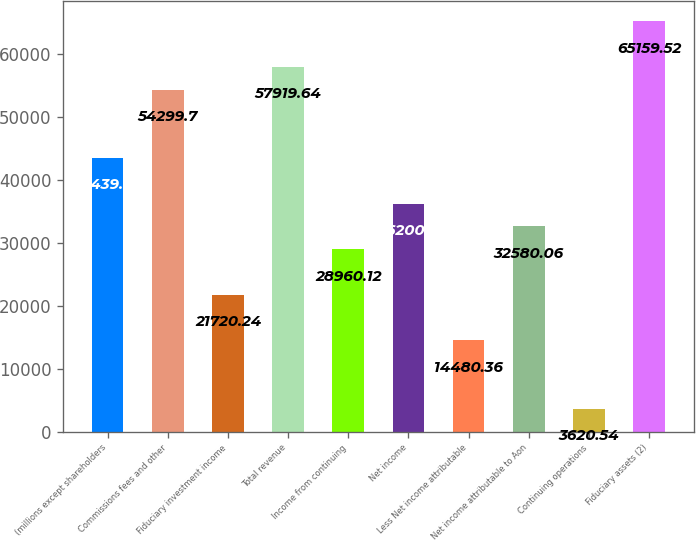Convert chart. <chart><loc_0><loc_0><loc_500><loc_500><bar_chart><fcel>(millions except shareholders<fcel>Commissions fees and other<fcel>Fiduciary investment income<fcel>Total revenue<fcel>Income from continuing<fcel>Net income<fcel>Less Net income attributable<fcel>Net income attributable to Aon<fcel>Continuing operations<fcel>Fiduciary assets (2)<nl><fcel>43439.9<fcel>54299.7<fcel>21720.2<fcel>57919.6<fcel>28960.1<fcel>36200<fcel>14480.4<fcel>32580.1<fcel>3620.54<fcel>65159.5<nl></chart> 